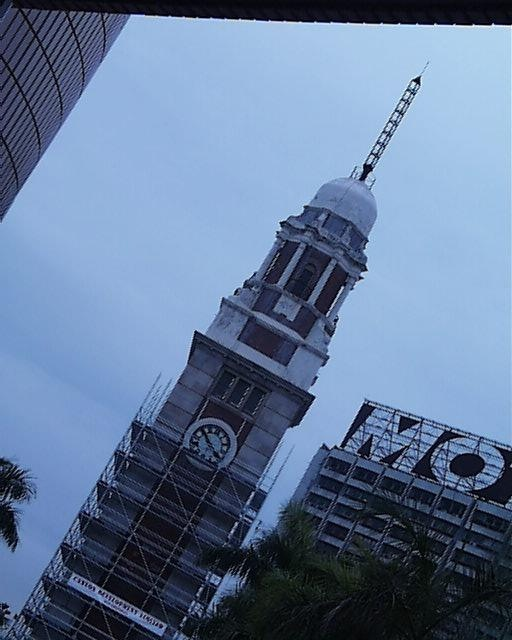Describe the objects in this image and their specific colors. I can see a clock in black, navy, gray, and darkblue tones in this image. 